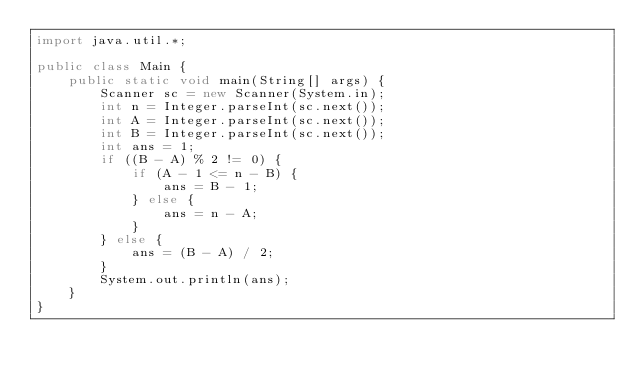Convert code to text. <code><loc_0><loc_0><loc_500><loc_500><_Java_>import java.util.*;

public class Main {
	public static void main(String[] args) {
		Scanner sc = new Scanner(System.in);
		int n = Integer.parseInt(sc.next());
		int A = Integer.parseInt(sc.next());
		int B = Integer.parseInt(sc.next());
		int ans = 1;
		if ((B - A) % 2 != 0) {
			if (A - 1 <= n - B) {
				ans = B - 1;
			} else {
				ans = n - A;
			}
		} else {
			ans = (B - A) / 2;
		}
		System.out.println(ans);
	}
}</code> 